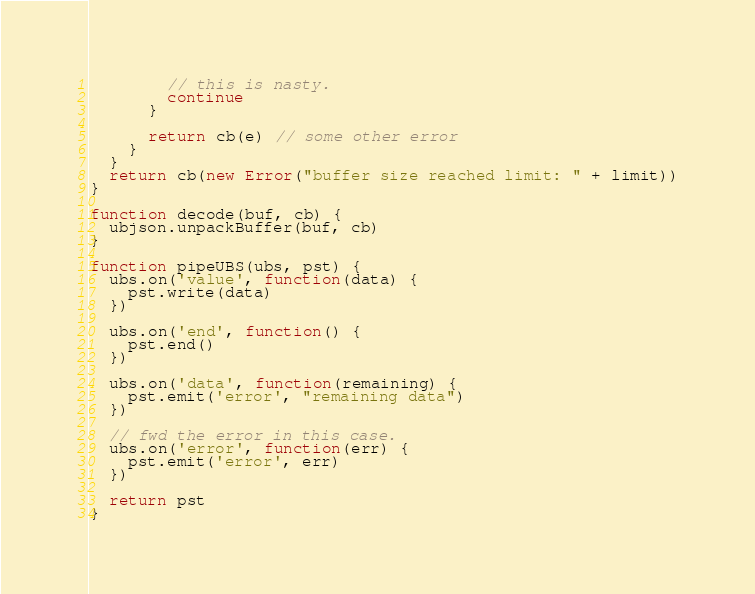Convert code to text. <code><loc_0><loc_0><loc_500><loc_500><_JavaScript_>        // this is nasty.
        continue
      }

      return cb(e) // some other error
    }
  }
  return cb(new Error("buffer size reached limit: " + limit))
}

function decode(buf, cb) {
  ubjson.unpackBuffer(buf, cb)
}

function pipeUBS(ubs, pst) {
  ubs.on('value', function(data) {
    pst.write(data)
  })

  ubs.on('end', function() {
    pst.end()
  })

  ubs.on('data', function(remaining) {
    pst.emit('error', "remaining data")
  })

  // fwd the error in this case.
  ubs.on('error', function(err) {
    pst.emit('error', err)
  })

  return pst
}</code> 